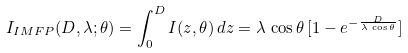<formula> <loc_0><loc_0><loc_500><loc_500>I _ { I M F P } ( D , \lambda ; \theta ) = \int _ { 0 } ^ { D } I ( z , \theta ) \, d z = \lambda \, \cos \theta \, [ 1 - e ^ { - \frac { D } { \lambda \, \cos \theta } } ]</formula> 